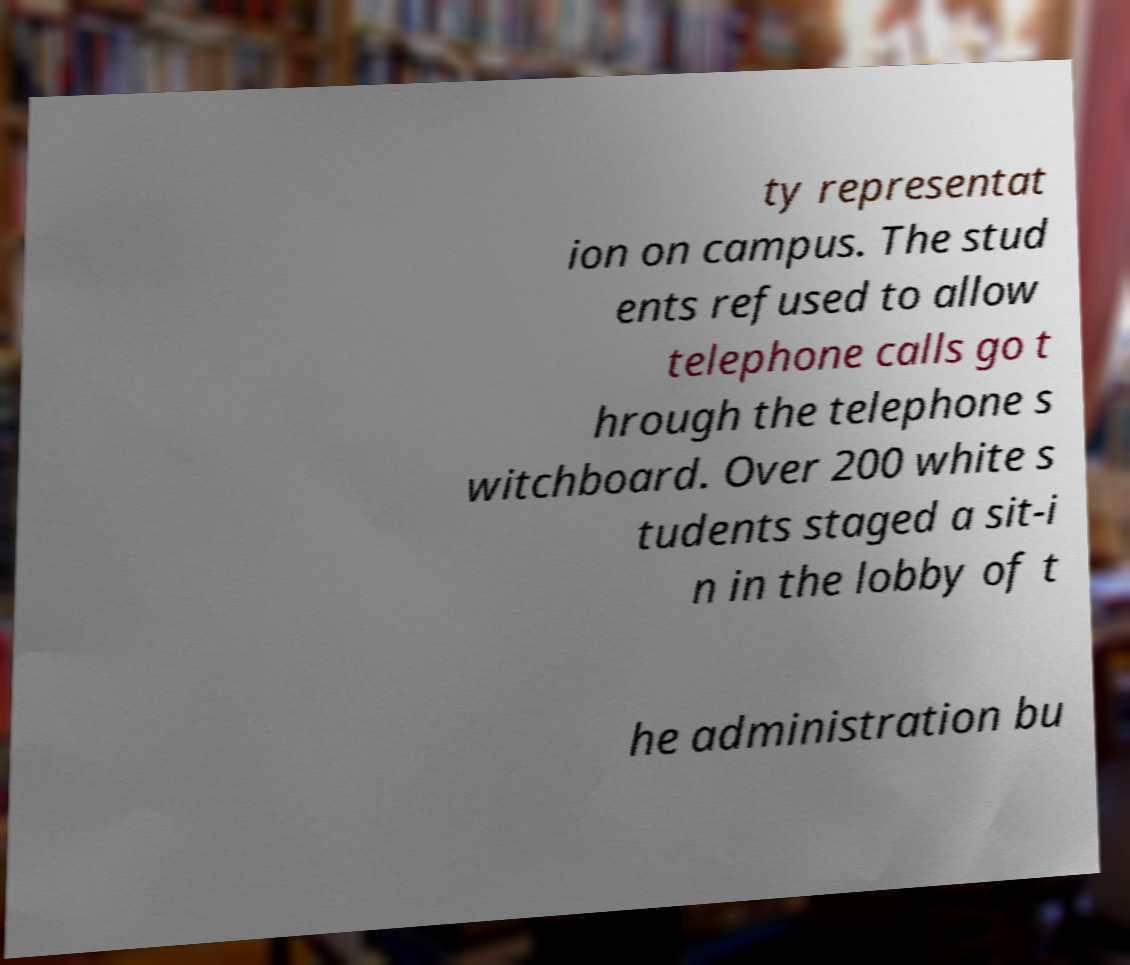For documentation purposes, I need the text within this image transcribed. Could you provide that? ty representat ion on campus. The stud ents refused to allow telephone calls go t hrough the telephone s witchboard. Over 200 white s tudents staged a sit-i n in the lobby of t he administration bu 